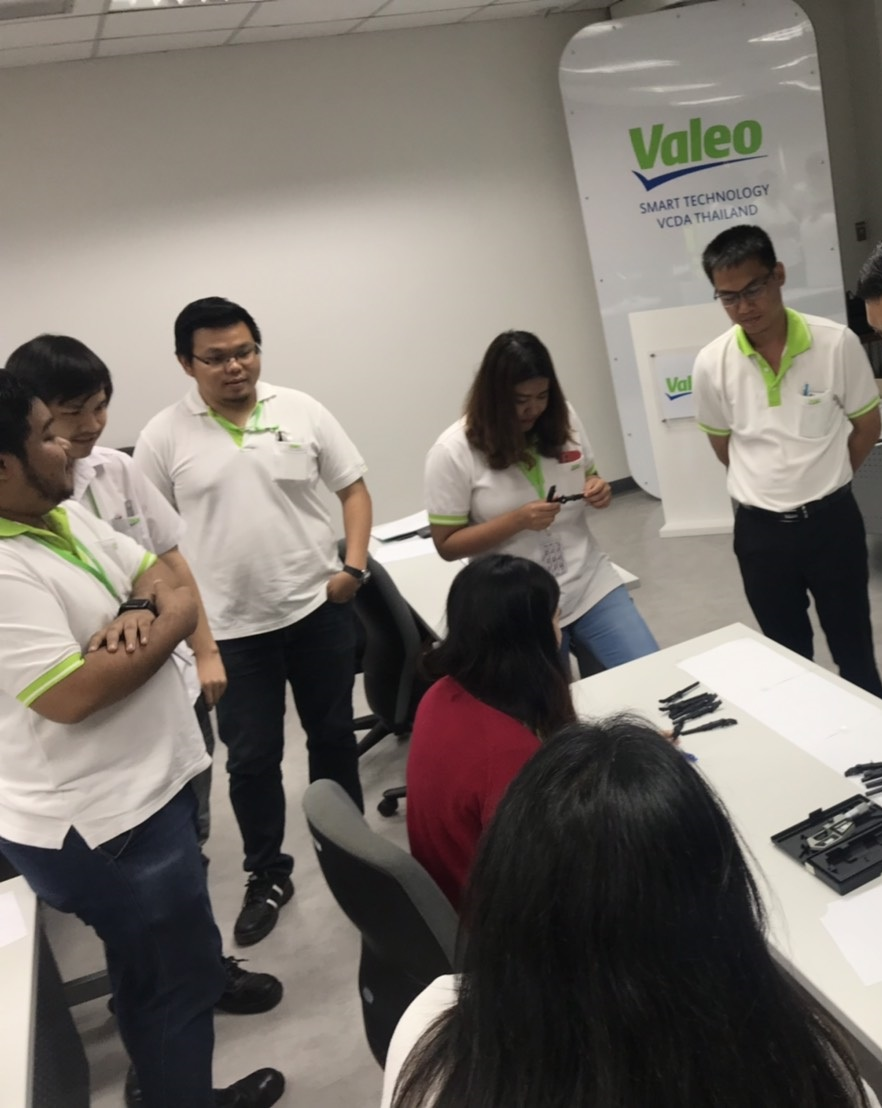What might be the topic or nature of the discussion based on the objects and environment seen around the group? Considering the visual elements present in the photograph, the group is likely engaged in a technology or innovation-related discussion, predominantly centered around the company 'Valeo,' as indicated by the promotional material. The attire of the participants suggests a corporate event or an internal meeting, possibly focusing on employee training or collaborative project development. The ambiance is informal yet focused, consistent with brainstorming sessions or strategic meetings. Visible documents and pens hint at an interactive element, likely involving data analysis, project management, or creative strategizing, aiming to harness collective intelligence and teamwork to foster new insights or solutions within the smart technology sector. 